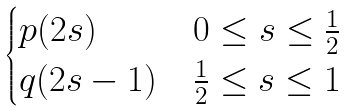Convert formula to latex. <formula><loc_0><loc_0><loc_500><loc_500>\begin{cases} p ( 2 s ) & 0 \leq s \leq \frac { 1 } { 2 } \\ q ( 2 s - 1 ) & \frac { 1 } { 2 } \leq s \leq 1 \end{cases}</formula> 